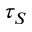Convert formula to latex. <formula><loc_0><loc_0><loc_500><loc_500>\tau _ { S }</formula> 